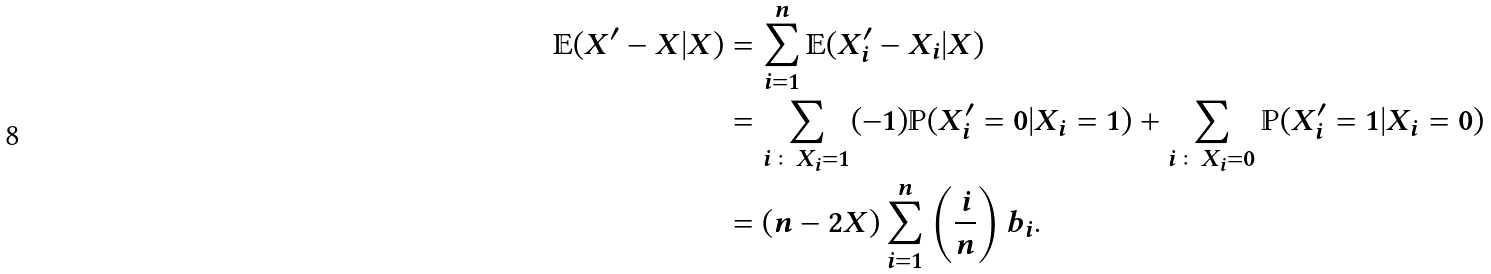Convert formula to latex. <formula><loc_0><loc_0><loc_500><loc_500>\mathbb { E } ( X ^ { \prime } - X | X ) & = \sum _ { i = 1 } ^ { n } \mathbb { E } ( X _ { i } ^ { \prime } - X _ { i } | X ) \\ & = \sum _ { i \colon X _ { i } = 1 } ( - 1 ) \mathbb { P } ( X _ { i } ^ { \prime } = 0 | X _ { i } = 1 ) + \sum _ { i \colon X _ { i } = 0 } \mathbb { P } ( X _ { i } ^ { \prime } = 1 | X _ { i } = 0 ) \\ & = ( n - 2 X ) \sum _ { i = 1 } ^ { n } \left ( \frac { i } { n } \right ) b _ { i } .</formula> 